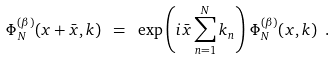Convert formula to latex. <formula><loc_0><loc_0><loc_500><loc_500>\Phi _ { N } ^ { ( \beta ) } ( x + \bar { x } , k ) \ = \ \exp \left ( i \bar { x } \sum _ { n = 1 } ^ { N } k _ { n } \right ) \, \Phi _ { N } ^ { ( \beta ) } ( x , k ) \ .</formula> 